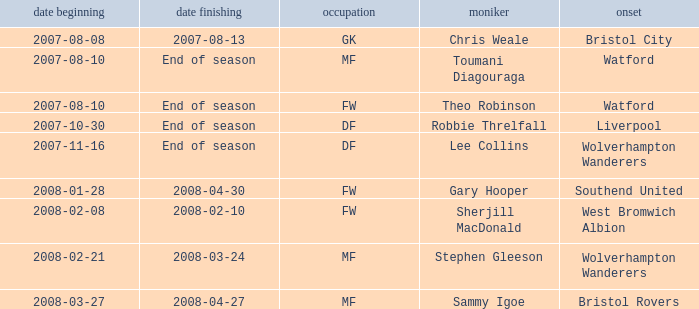I'm looking to parse the entire table for insights. Could you assist me with that? {'header': ['date beginning', 'date finishing', 'occupation', 'moniker', 'onset'], 'rows': [['2007-08-08', '2007-08-13', 'GK', 'Chris Weale', 'Bristol City'], ['2007-08-10', 'End of season', 'MF', 'Toumani Diagouraga', 'Watford'], ['2007-08-10', 'End of season', 'FW', 'Theo Robinson', 'Watford'], ['2007-10-30', 'End of season', 'DF', 'Robbie Threlfall', 'Liverpool'], ['2007-11-16', 'End of season', 'DF', 'Lee Collins', 'Wolverhampton Wanderers'], ['2008-01-28', '2008-04-30', 'FW', 'Gary Hooper', 'Southend United'], ['2008-02-08', '2008-02-10', 'FW', 'Sherjill MacDonald', 'West Bromwich Albion'], ['2008-02-21', '2008-03-24', 'MF', 'Stephen Gleeson', 'Wolverhampton Wanderers'], ['2008-03-27', '2008-04-27', 'MF', 'Sammy Igoe', 'Bristol Rovers']]} What was the from for the Date From of 2007-08-08? Bristol City. 